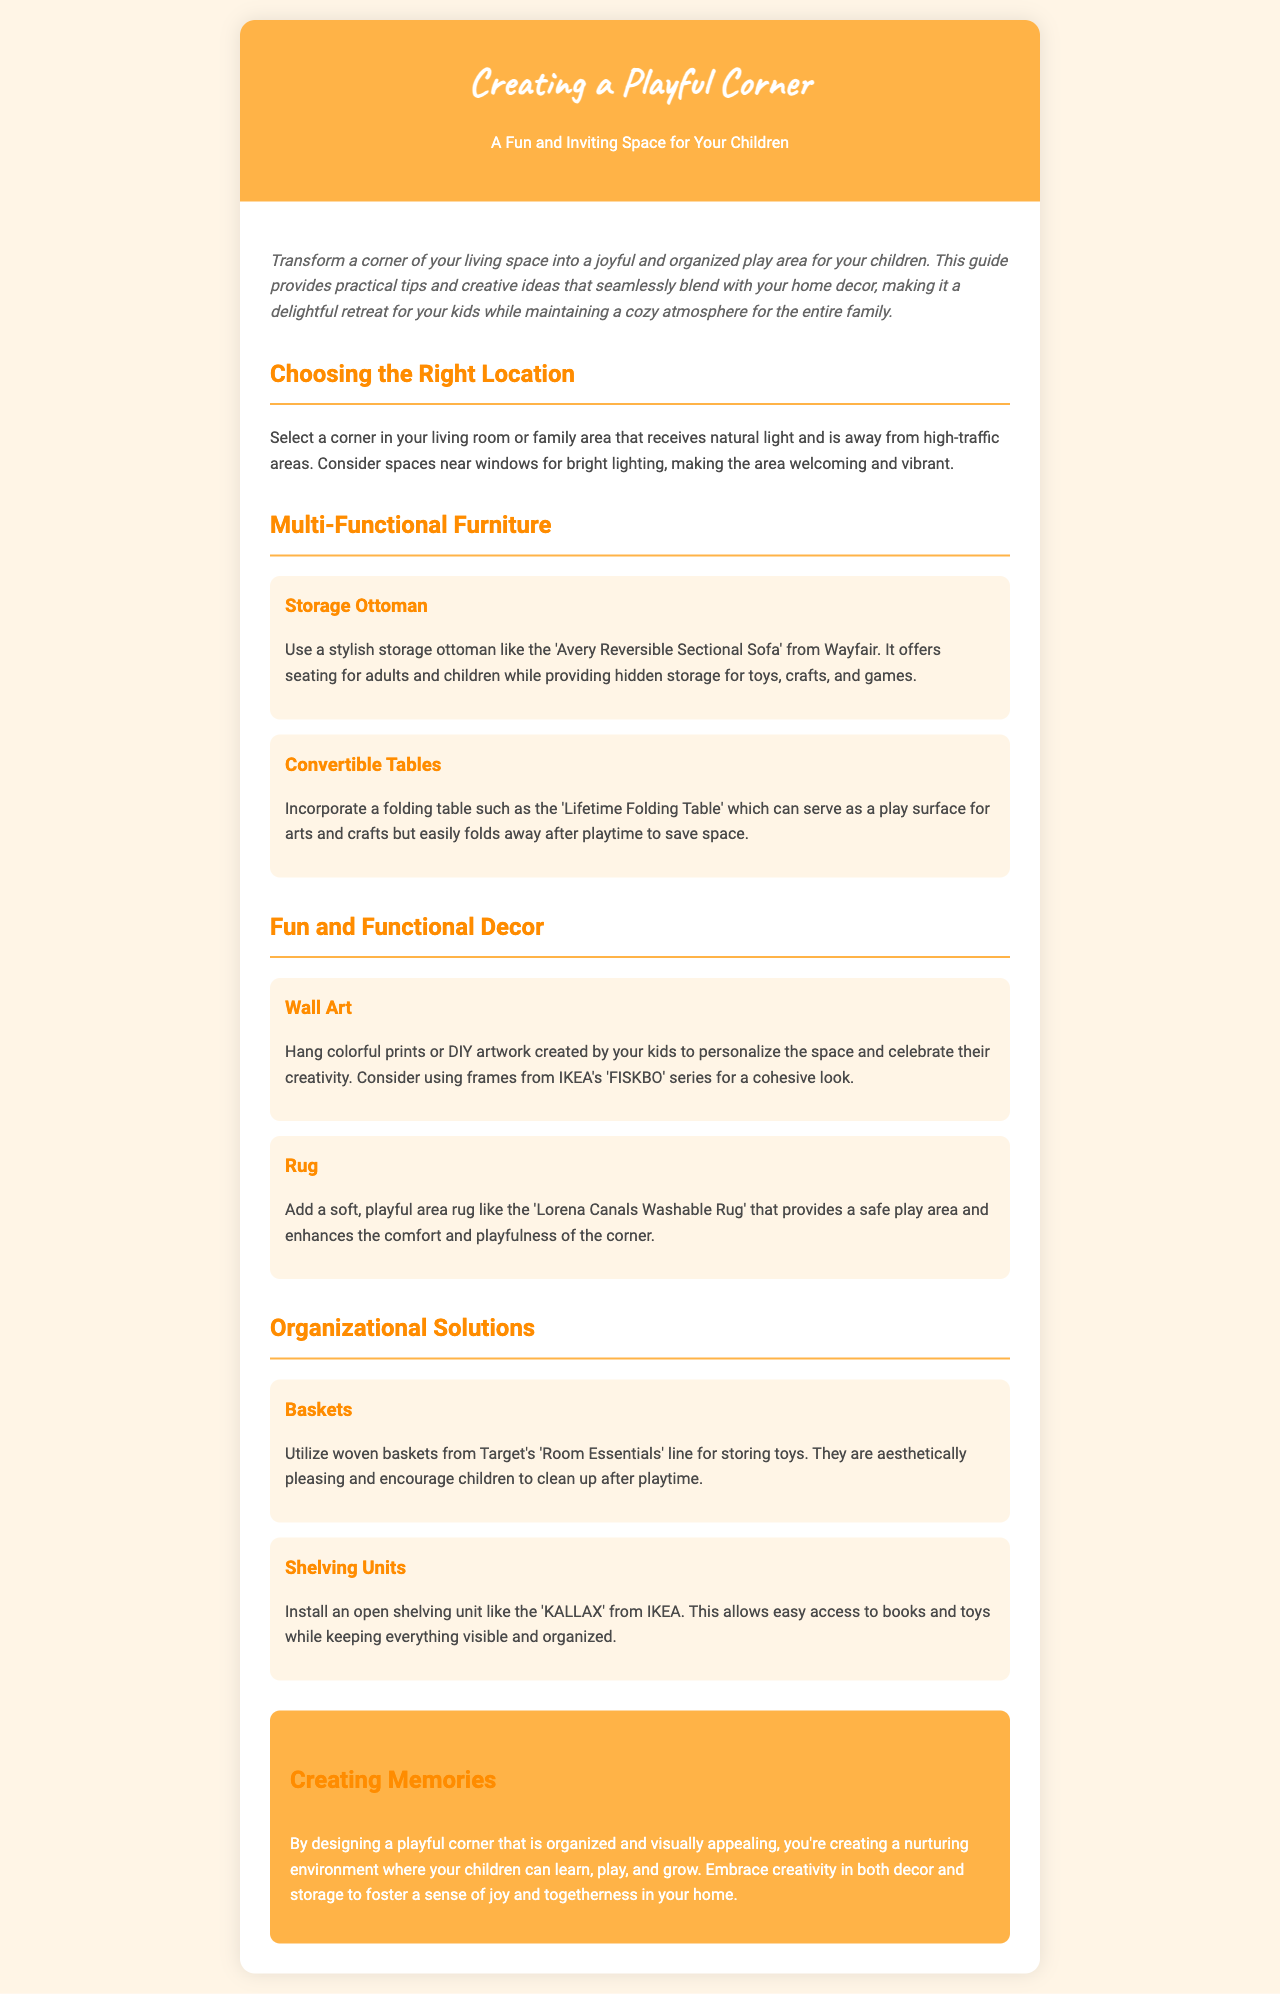what is the title of the brochure? The title of the brochure is prominently displayed at the top, indicating the main topic of the content.
Answer: Creating a Playful Corner what is a recommended storage solution mentioned? The document lists specific items that can be used for storage, such as baskets and ottomans.
Answer: Storage Ottoman which furniture type is suggested for arts and crafts? The document mentions a specific folding table that serves this purpose.
Answer: Convertible Tables what color are the prints suggested for wall art? The document suggests a particular visual theme for the wall decor.
Answer: Colorful which brand features the shelving unit recommended? The brochure provides a specific brand and product name related to shelving.
Answer: IKEA how should baskets be used in the play area? The document describes how baskets can help with organization and encourage cleanup.
Answer: Storing toys what type of area rug is suggested? The document includes a specific description and product style for the rug.
Answer: Washable Rug what is the conclusion about the playful corner? The brochure sums up its purpose and importance in the home environment.
Answer: Creating memories 